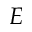Convert formula to latex. <formula><loc_0><loc_0><loc_500><loc_500>E</formula> 